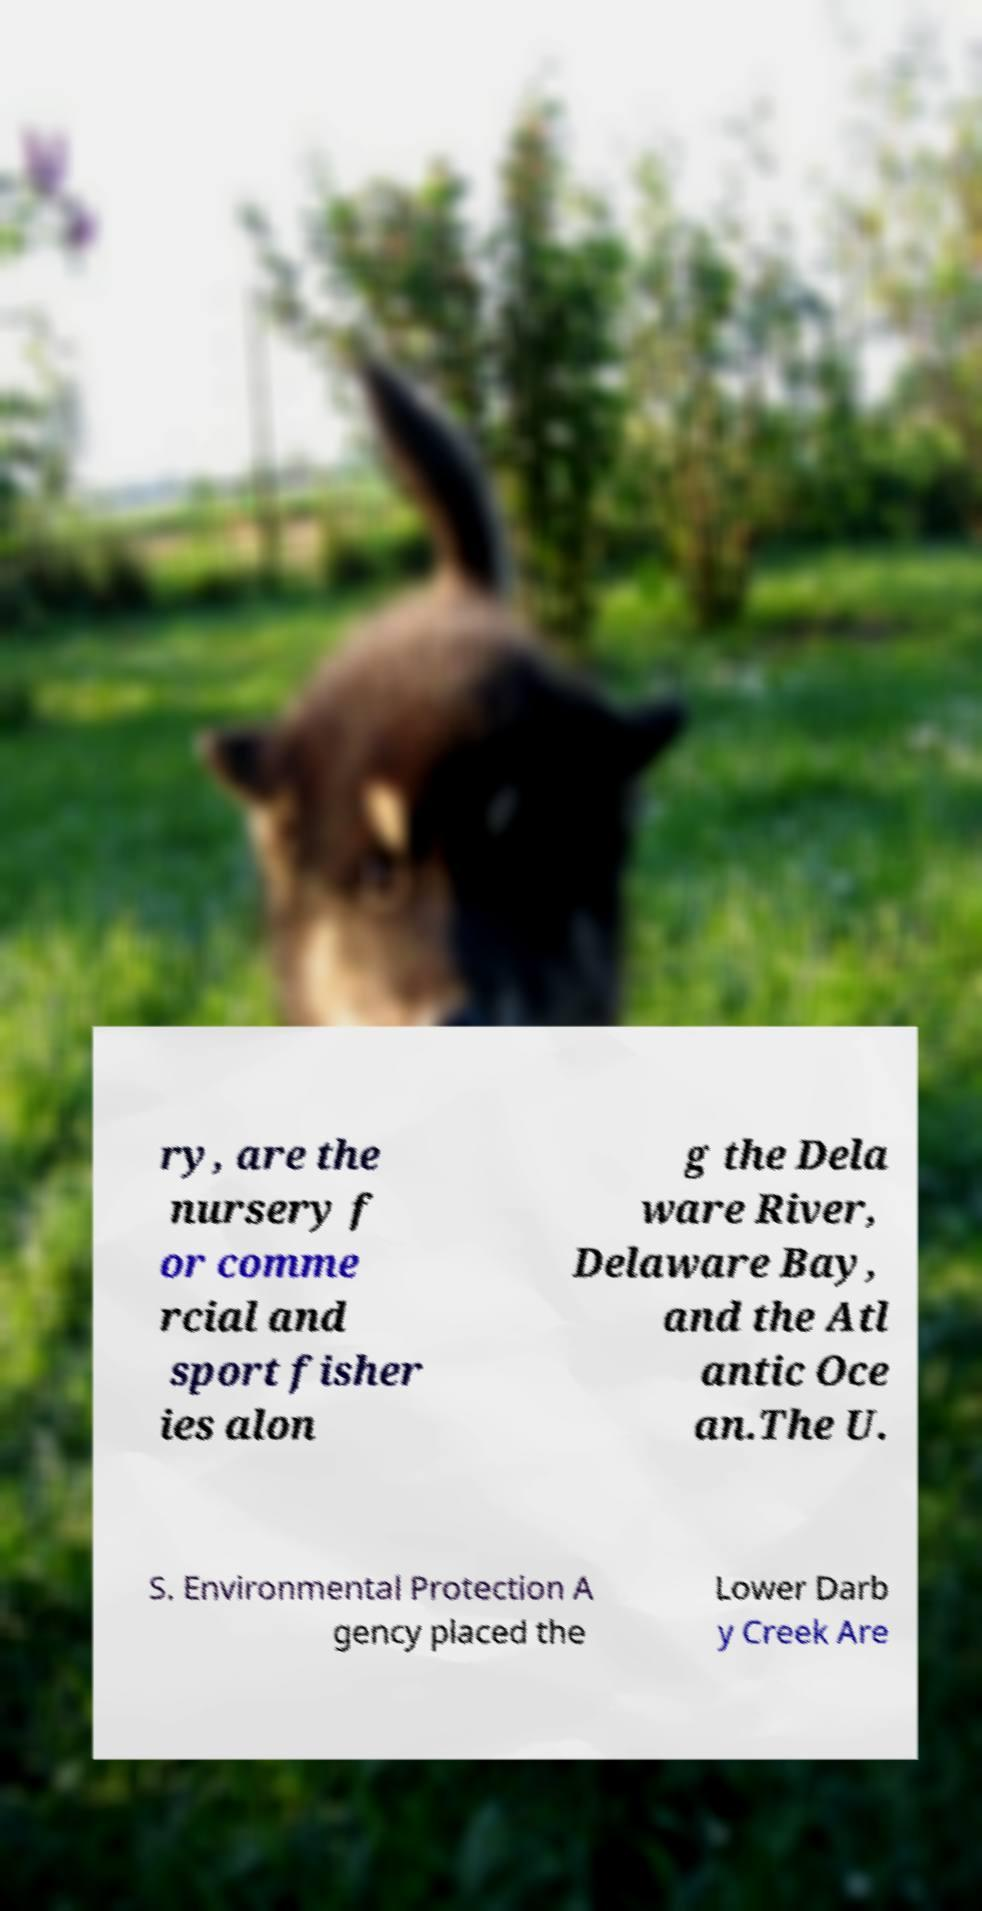Could you assist in decoding the text presented in this image and type it out clearly? ry, are the nursery f or comme rcial and sport fisher ies alon g the Dela ware River, Delaware Bay, and the Atl antic Oce an.The U. S. Environmental Protection A gency placed the Lower Darb y Creek Are 